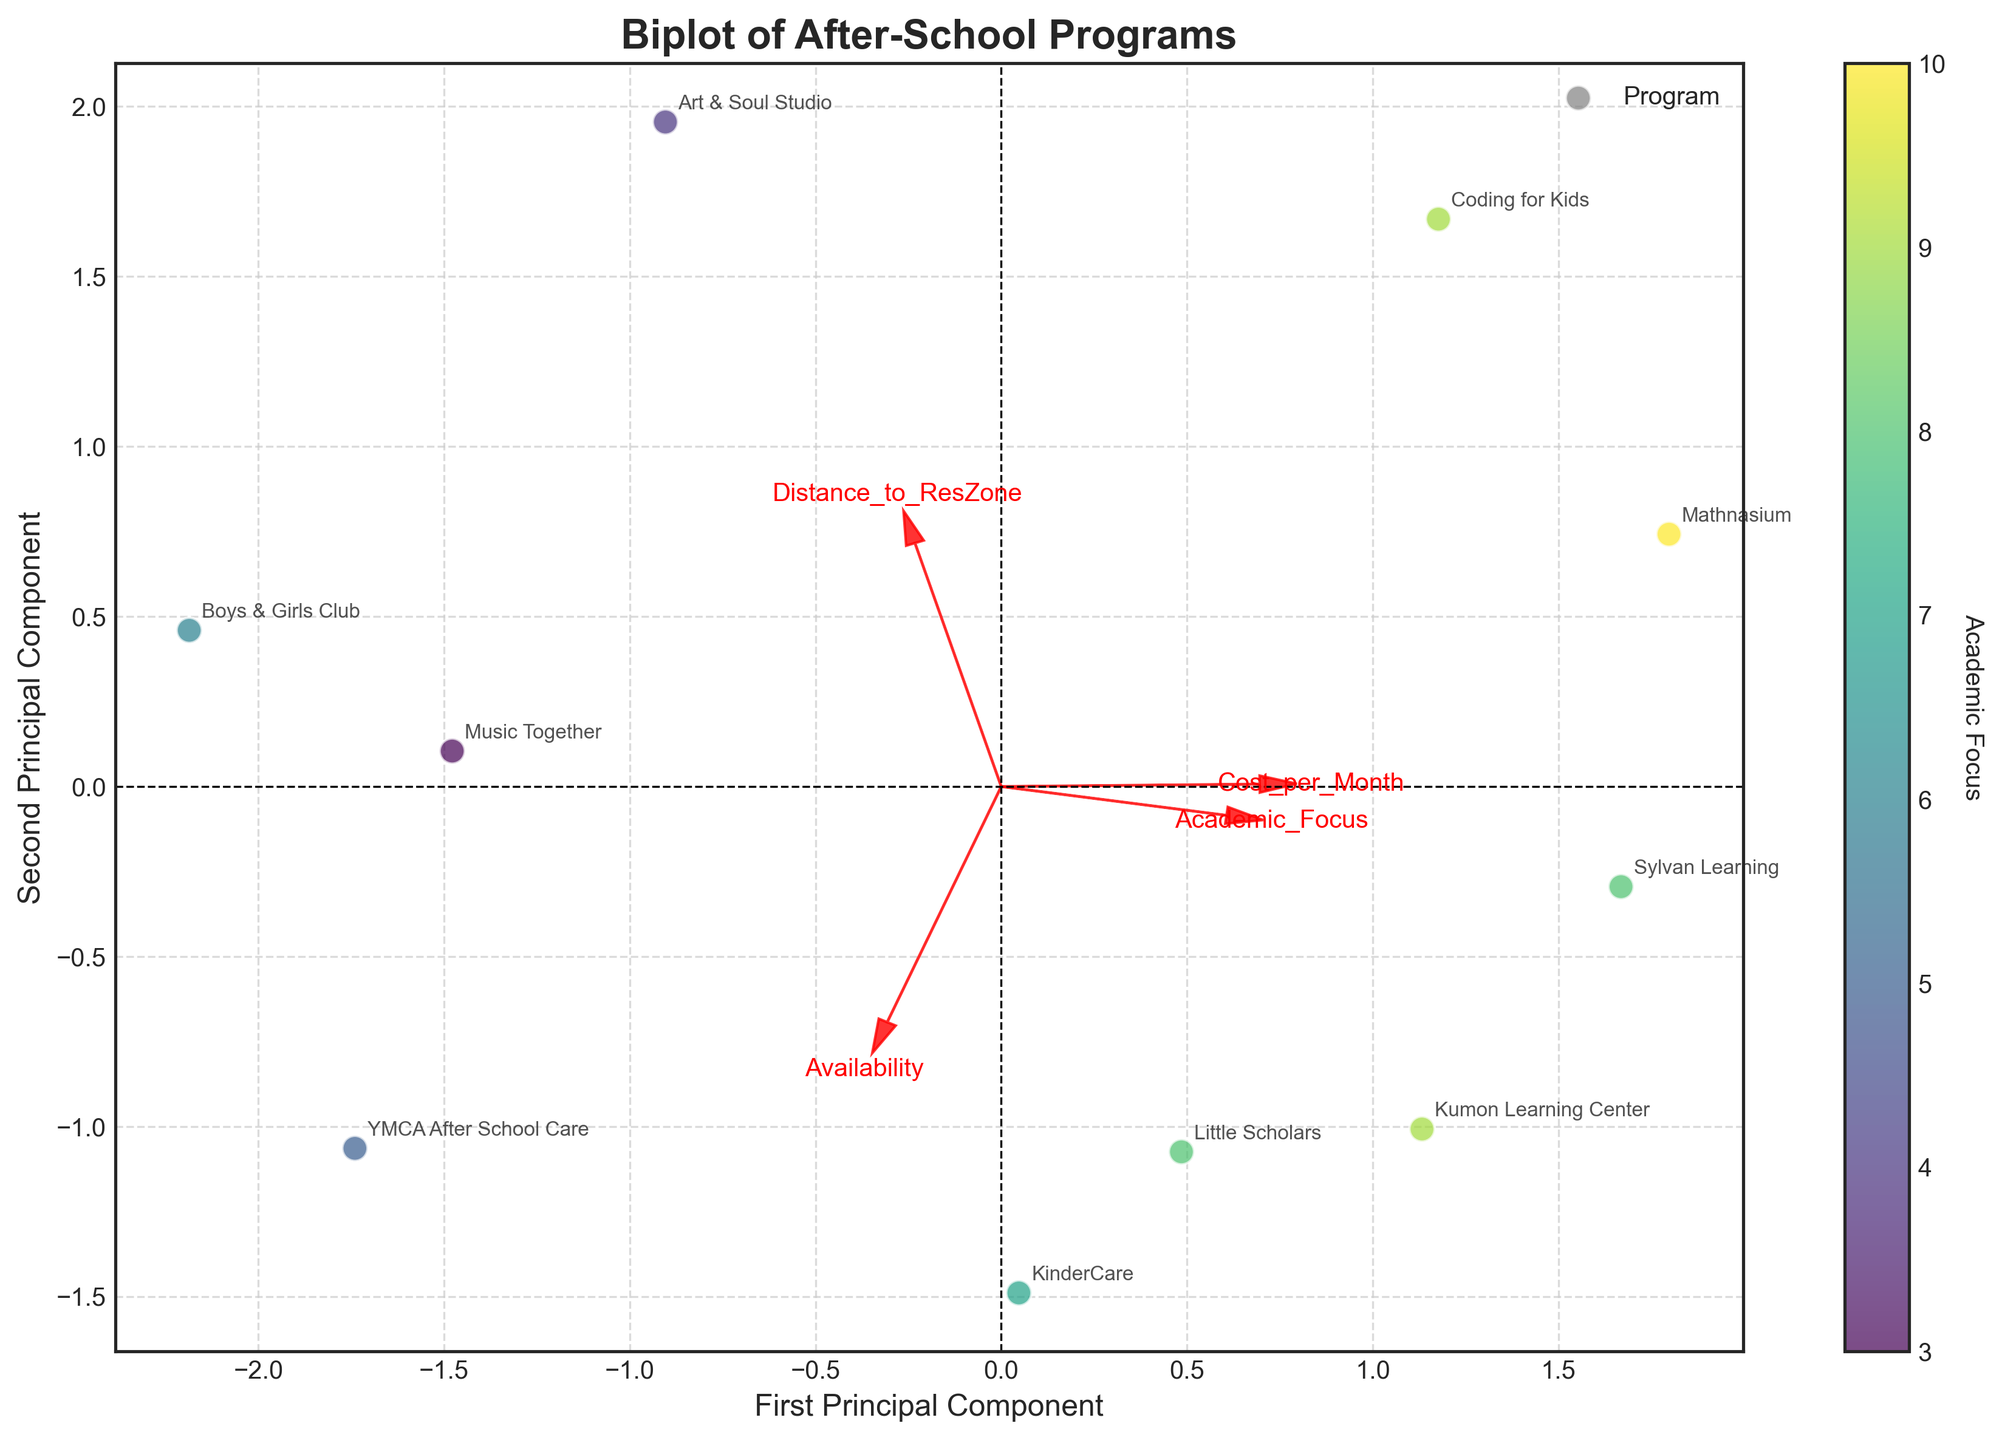what's the title of the figure? The title of the figure is positioned prominently at the top of the chart. We can read it directly from the plot.
Answer: Biplot of After-School Programs how many after-school programs are represented in the plot? Each dot on the plot represents an after-school program. By counting these dots, we see there are 10 programs represented.
Answer: 10 what does the color coding of the dots represent? The color gradient visible on the dots has a corresponding color bar labeled 'Academic Focus.' Hence, the color coding represents the 'Academic Focus' level of each after-school program.
Answer: Academic Focus which after-school program is the closest to the residential zone? To determine the closest program, we look for the one with the lowest value on the arrow labeled 'Distance_to_ResZone.' According to the plot, 'KinderCare' is closest to the residential zone.
Answer: KinderCare which feature vector is the longest in the biplot? The feature vector's length can be assessed by the size of the arrows originating from the plot's origin. The 'Availability' vector appears to be the longest among the displayed features.
Answer: Availability which program offers the highest academic focus and what is its distance from the residential zone? From the plot, we find the dot with the darkest color, indicating the highest academic focus. 'Mathnasium' is such a dot, and its distance from the residential zone can be inferred from its position in relation to the 'Distance_to_ResZone' arrow, which is higher than many other programs.
Answer: Mathnasium, 1.5 is there a relationship between academic focus and cost per month? We can infer the relationship by observing the alignment of dots along the arrows of 'Academic_Focus' and 'Cost_per_Month.' If dots with higher academic focus also tend to align closer to the 'Cost_per_Month,' it indicates a relationship. There seems to be a trend that higher academic focus programs have a higher cost.
Answer: Yes, higher academic focus tends to have higher costs which two programs are the most and least available? Availability is evident from the color gradient on the dots and vector lengths. Comparing the dots along the 'Availability' arrow, 'YMCA After School Care' seems the most available while 'Art & Soul Studio' appears to be the least.
Answer: YMCA After School Care, Art & Soul Studio what can you infer about the relationship between 'Distance_to_ResZone' and 'Cost_per_Month'? Observing the plot, dots close to the origin on the 'Distance_to_ResZone' arrow do not always correspond to their position on the 'Cost_per_Month' arrow. For example, 'KinderCare' is close to the residential zone and not the most expensive program. Thus, there is no clear direct relationship.
Answer: No clear direction 